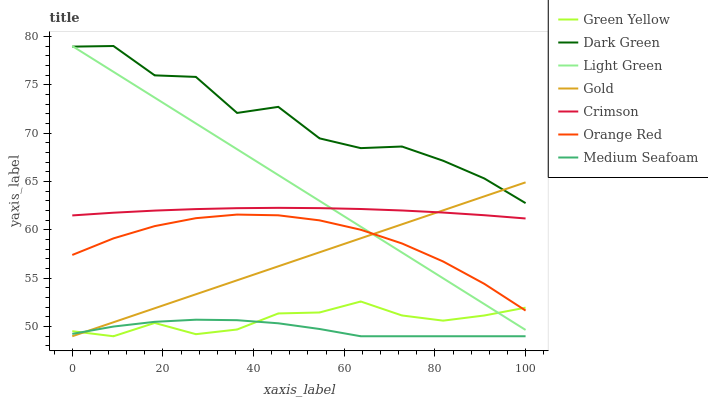Does Medium Seafoam have the minimum area under the curve?
Answer yes or no. Yes. Does Dark Green have the maximum area under the curve?
Answer yes or no. Yes. Does Light Green have the minimum area under the curve?
Answer yes or no. No. Does Light Green have the maximum area under the curve?
Answer yes or no. No. Is Light Green the smoothest?
Answer yes or no. Yes. Is Dark Green the roughest?
Answer yes or no. Yes. Is Medium Seafoam the smoothest?
Answer yes or no. No. Is Medium Seafoam the roughest?
Answer yes or no. No. Does Gold have the lowest value?
Answer yes or no. Yes. Does Light Green have the lowest value?
Answer yes or no. No. Does Dark Green have the highest value?
Answer yes or no. Yes. Does Medium Seafoam have the highest value?
Answer yes or no. No. Is Medium Seafoam less than Orange Red?
Answer yes or no. Yes. Is Dark Green greater than Medium Seafoam?
Answer yes or no. Yes. Does Medium Seafoam intersect Gold?
Answer yes or no. Yes. Is Medium Seafoam less than Gold?
Answer yes or no. No. Is Medium Seafoam greater than Gold?
Answer yes or no. No. Does Medium Seafoam intersect Orange Red?
Answer yes or no. No. 